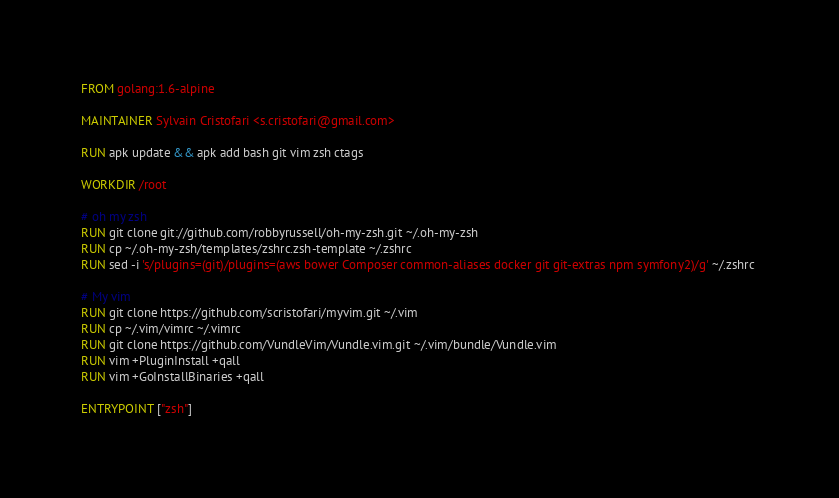Convert code to text. <code><loc_0><loc_0><loc_500><loc_500><_Dockerfile_>FROM golang:1.6-alpine

MAINTAINER Sylvain Cristofari <s.cristofari@gmail.com>

RUN apk update && apk add bash git vim zsh ctags

WORKDIR /root

# oh my zsh
RUN git clone git://github.com/robbyrussell/oh-my-zsh.git ~/.oh-my-zsh
RUN cp ~/.oh-my-zsh/templates/zshrc.zsh-template ~/.zshrc
RUN sed -i 's/plugins=(git)/plugins=(aws bower Composer common-aliases docker git git-extras npm symfony2)/g' ~/.zshrc 

# My vim
RUN git clone https://github.com/scristofari/myvim.git ~/.vim
RUN cp ~/.vim/vimrc ~/.vimrc
RUN git clone https://github.com/VundleVim/Vundle.vim.git ~/.vim/bundle/Vundle.vim
RUN vim +PluginInstall +qall
RUN vim +GoInstallBinaries +qall

ENTRYPOINT ["zsh"]
</code> 